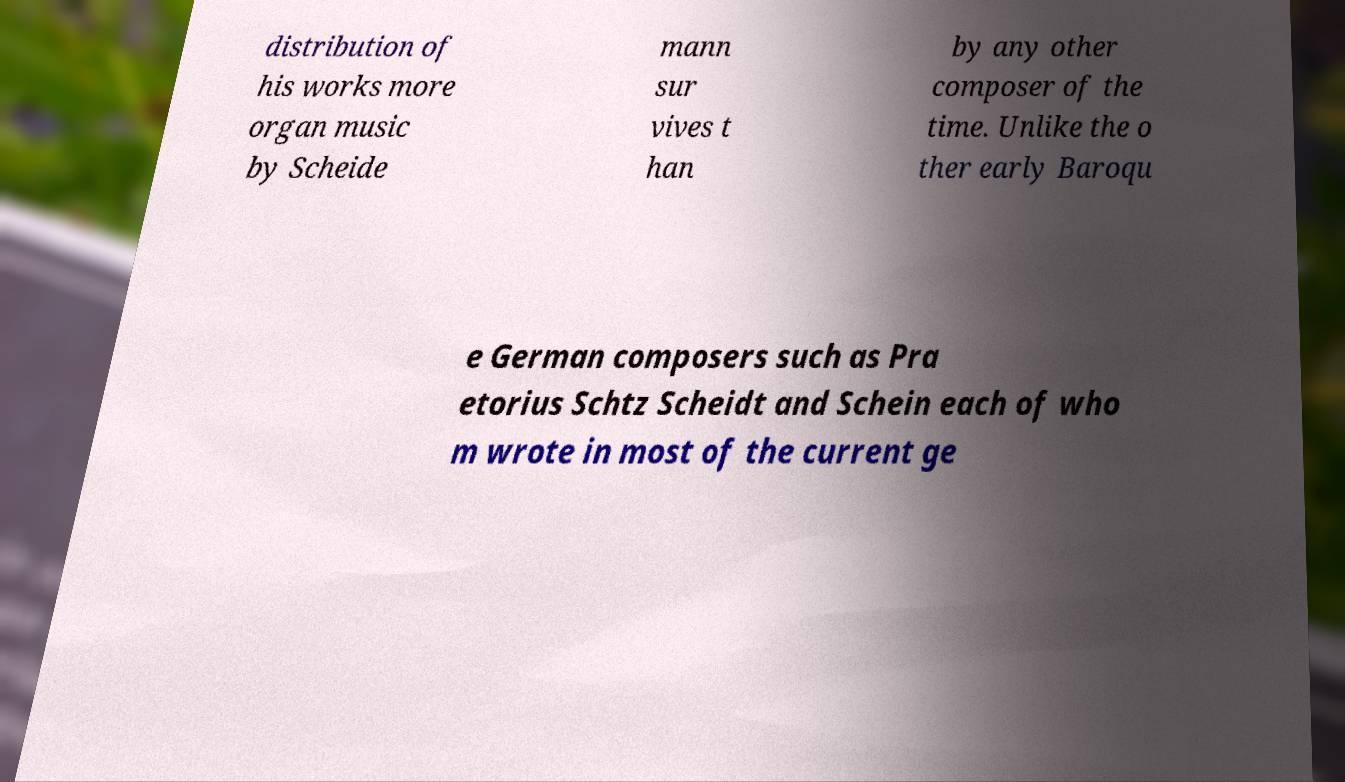For documentation purposes, I need the text within this image transcribed. Could you provide that? distribution of his works more organ music by Scheide mann sur vives t han by any other composer of the time. Unlike the o ther early Baroqu e German composers such as Pra etorius Schtz Scheidt and Schein each of who m wrote in most of the current ge 